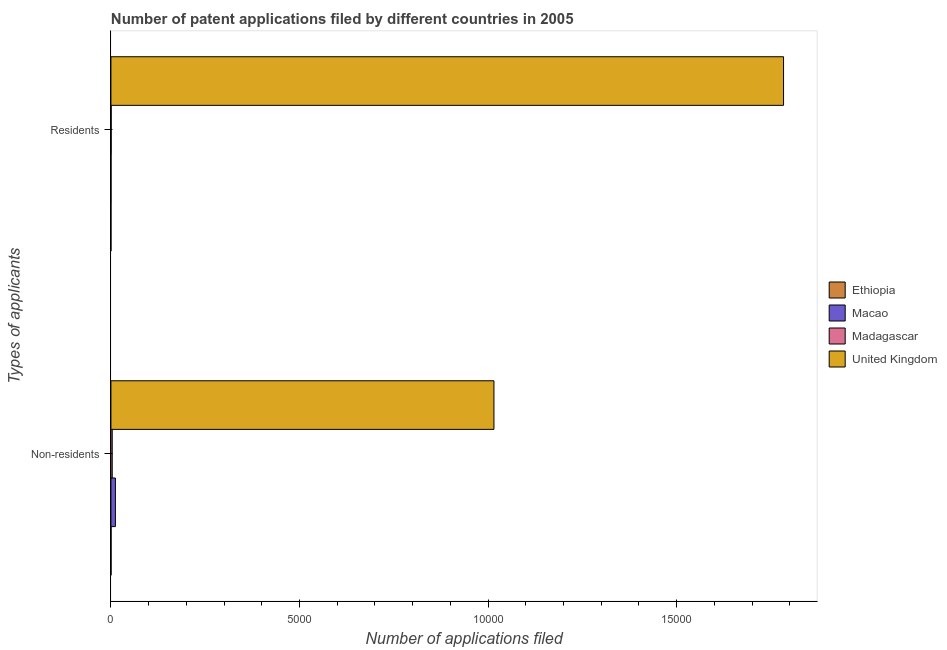How many different coloured bars are there?
Keep it short and to the point. 4. How many groups of bars are there?
Your response must be concise. 2. How many bars are there on the 1st tick from the top?
Provide a succinct answer. 4. What is the label of the 2nd group of bars from the top?
Keep it short and to the point. Non-residents. What is the number of patent applications by residents in Macao?
Offer a very short reply. 3. Across all countries, what is the maximum number of patent applications by non residents?
Your response must be concise. 1.02e+04. Across all countries, what is the minimum number of patent applications by non residents?
Offer a terse response. 4. In which country was the number of patent applications by residents minimum?
Keep it short and to the point. Ethiopia. What is the total number of patent applications by residents in the graph?
Your response must be concise. 1.78e+04. What is the difference between the number of patent applications by residents in Madagascar and that in Ethiopia?
Keep it short and to the point. 6. What is the difference between the number of patent applications by non residents in Macao and the number of patent applications by residents in United Kingdom?
Make the answer very short. -1.77e+04. What is the average number of patent applications by residents per country?
Ensure brevity in your answer.  4461. What is the difference between the number of patent applications by residents and number of patent applications by non residents in Macao?
Provide a succinct answer. -116. In how many countries, is the number of patent applications by non residents greater than 7000 ?
Provide a short and direct response. 1. What is the ratio of the number of patent applications by non residents in United Kingdom to that in Macao?
Provide a short and direct response. 85.34. Is the number of patent applications by non residents in United Kingdom less than that in Madagascar?
Make the answer very short. No. What does the 1st bar from the top in Non-residents represents?
Your answer should be very brief. United Kingdom. What does the 1st bar from the bottom in Non-residents represents?
Provide a succinct answer. Ethiopia. How many bars are there?
Provide a succinct answer. 8. Are all the bars in the graph horizontal?
Your response must be concise. Yes. How many countries are there in the graph?
Offer a terse response. 4. What is the difference between two consecutive major ticks on the X-axis?
Offer a very short reply. 5000. Does the graph contain any zero values?
Offer a very short reply. No. Does the graph contain grids?
Keep it short and to the point. No. How many legend labels are there?
Offer a terse response. 4. What is the title of the graph?
Ensure brevity in your answer.  Number of patent applications filed by different countries in 2005. What is the label or title of the X-axis?
Your answer should be very brief. Number of applications filed. What is the label or title of the Y-axis?
Provide a short and direct response. Types of applicants. What is the Number of applications filed of Ethiopia in Non-residents?
Your answer should be very brief. 4. What is the Number of applications filed in Macao in Non-residents?
Keep it short and to the point. 119. What is the Number of applications filed of United Kingdom in Non-residents?
Keep it short and to the point. 1.02e+04. What is the Number of applications filed in Ethiopia in Residents?
Your answer should be very brief. 1. What is the Number of applications filed of Madagascar in Residents?
Provide a short and direct response. 7. What is the Number of applications filed in United Kingdom in Residents?
Make the answer very short. 1.78e+04. Across all Types of applicants, what is the maximum Number of applications filed in Macao?
Offer a very short reply. 119. Across all Types of applicants, what is the maximum Number of applications filed of Madagascar?
Your response must be concise. 35. Across all Types of applicants, what is the maximum Number of applications filed of United Kingdom?
Provide a succinct answer. 1.78e+04. Across all Types of applicants, what is the minimum Number of applications filed in Ethiopia?
Provide a short and direct response. 1. Across all Types of applicants, what is the minimum Number of applications filed in United Kingdom?
Make the answer very short. 1.02e+04. What is the total Number of applications filed in Macao in the graph?
Give a very brief answer. 122. What is the total Number of applications filed of United Kingdom in the graph?
Provide a succinct answer. 2.80e+04. What is the difference between the Number of applications filed in Ethiopia in Non-residents and that in Residents?
Make the answer very short. 3. What is the difference between the Number of applications filed of Macao in Non-residents and that in Residents?
Ensure brevity in your answer.  116. What is the difference between the Number of applications filed in Madagascar in Non-residents and that in Residents?
Your answer should be very brief. 28. What is the difference between the Number of applications filed of United Kingdom in Non-residents and that in Residents?
Your answer should be very brief. -7678. What is the difference between the Number of applications filed of Ethiopia in Non-residents and the Number of applications filed of Macao in Residents?
Provide a succinct answer. 1. What is the difference between the Number of applications filed in Ethiopia in Non-residents and the Number of applications filed in Madagascar in Residents?
Keep it short and to the point. -3. What is the difference between the Number of applications filed of Ethiopia in Non-residents and the Number of applications filed of United Kingdom in Residents?
Provide a short and direct response. -1.78e+04. What is the difference between the Number of applications filed in Macao in Non-residents and the Number of applications filed in Madagascar in Residents?
Offer a very short reply. 112. What is the difference between the Number of applications filed in Macao in Non-residents and the Number of applications filed in United Kingdom in Residents?
Provide a succinct answer. -1.77e+04. What is the difference between the Number of applications filed in Madagascar in Non-residents and the Number of applications filed in United Kingdom in Residents?
Provide a succinct answer. -1.78e+04. What is the average Number of applications filed of Macao per Types of applicants?
Ensure brevity in your answer.  61. What is the average Number of applications filed in United Kingdom per Types of applicants?
Keep it short and to the point. 1.40e+04. What is the difference between the Number of applications filed of Ethiopia and Number of applications filed of Macao in Non-residents?
Your response must be concise. -115. What is the difference between the Number of applications filed of Ethiopia and Number of applications filed of Madagascar in Non-residents?
Ensure brevity in your answer.  -31. What is the difference between the Number of applications filed of Ethiopia and Number of applications filed of United Kingdom in Non-residents?
Your response must be concise. -1.02e+04. What is the difference between the Number of applications filed of Macao and Number of applications filed of United Kingdom in Non-residents?
Offer a very short reply. -1.00e+04. What is the difference between the Number of applications filed in Madagascar and Number of applications filed in United Kingdom in Non-residents?
Ensure brevity in your answer.  -1.01e+04. What is the difference between the Number of applications filed in Ethiopia and Number of applications filed in Madagascar in Residents?
Offer a terse response. -6. What is the difference between the Number of applications filed in Ethiopia and Number of applications filed in United Kingdom in Residents?
Provide a short and direct response. -1.78e+04. What is the difference between the Number of applications filed in Macao and Number of applications filed in Madagascar in Residents?
Your answer should be very brief. -4. What is the difference between the Number of applications filed in Macao and Number of applications filed in United Kingdom in Residents?
Keep it short and to the point. -1.78e+04. What is the difference between the Number of applications filed of Madagascar and Number of applications filed of United Kingdom in Residents?
Provide a short and direct response. -1.78e+04. What is the ratio of the Number of applications filed of Macao in Non-residents to that in Residents?
Offer a very short reply. 39.67. What is the ratio of the Number of applications filed of United Kingdom in Non-residents to that in Residents?
Provide a succinct answer. 0.57. What is the difference between the highest and the second highest Number of applications filed of Ethiopia?
Provide a short and direct response. 3. What is the difference between the highest and the second highest Number of applications filed in Macao?
Give a very brief answer. 116. What is the difference between the highest and the second highest Number of applications filed in Madagascar?
Keep it short and to the point. 28. What is the difference between the highest and the second highest Number of applications filed in United Kingdom?
Your response must be concise. 7678. What is the difference between the highest and the lowest Number of applications filed of Ethiopia?
Make the answer very short. 3. What is the difference between the highest and the lowest Number of applications filed of Macao?
Your response must be concise. 116. What is the difference between the highest and the lowest Number of applications filed in Madagascar?
Your response must be concise. 28. What is the difference between the highest and the lowest Number of applications filed of United Kingdom?
Provide a short and direct response. 7678. 